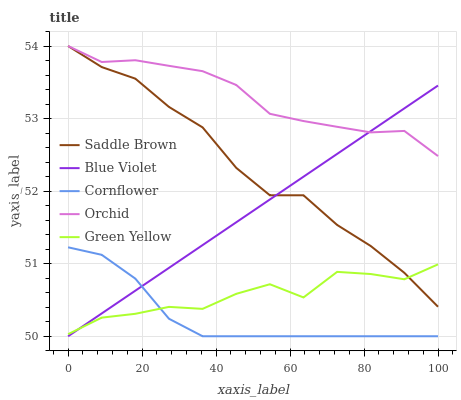Does Cornflower have the minimum area under the curve?
Answer yes or no. Yes. Does Orchid have the maximum area under the curve?
Answer yes or no. Yes. Does Green Yellow have the minimum area under the curve?
Answer yes or no. No. Does Green Yellow have the maximum area under the curve?
Answer yes or no. No. Is Blue Violet the smoothest?
Answer yes or no. Yes. Is Green Yellow the roughest?
Answer yes or no. Yes. Is Saddle Brown the smoothest?
Answer yes or no. No. Is Saddle Brown the roughest?
Answer yes or no. No. Does Green Yellow have the lowest value?
Answer yes or no. No. Does Orchid have the highest value?
Answer yes or no. Yes. Does Green Yellow have the highest value?
Answer yes or no. No. Is Cornflower less than Saddle Brown?
Answer yes or no. Yes. Is Orchid greater than Green Yellow?
Answer yes or no. Yes. Does Blue Violet intersect Saddle Brown?
Answer yes or no. Yes. Is Blue Violet less than Saddle Brown?
Answer yes or no. No. Is Blue Violet greater than Saddle Brown?
Answer yes or no. No. Does Cornflower intersect Saddle Brown?
Answer yes or no. No. 